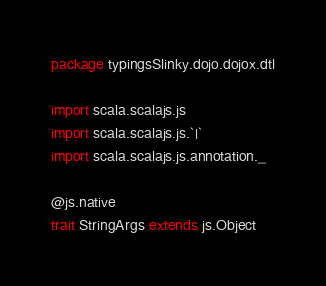Convert code to text. <code><loc_0><loc_0><loc_500><loc_500><_Scala_>package typingsSlinky.dojo.dojox.dtl

import scala.scalajs.js
import scala.scalajs.js.`|`
import scala.scalajs.js.annotation._

@js.native
trait StringArgs extends js.Object

</code> 